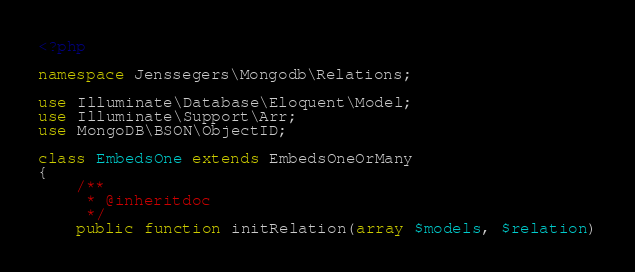Convert code to text. <code><loc_0><loc_0><loc_500><loc_500><_PHP_><?php

namespace Jenssegers\Mongodb\Relations;

use Illuminate\Database\Eloquent\Model;
use Illuminate\Support\Arr;
use MongoDB\BSON\ObjectID;

class EmbedsOne extends EmbedsOneOrMany
{
    /**
     * @inheritdoc
     */
    public function initRelation(array $models, $relation)</code> 